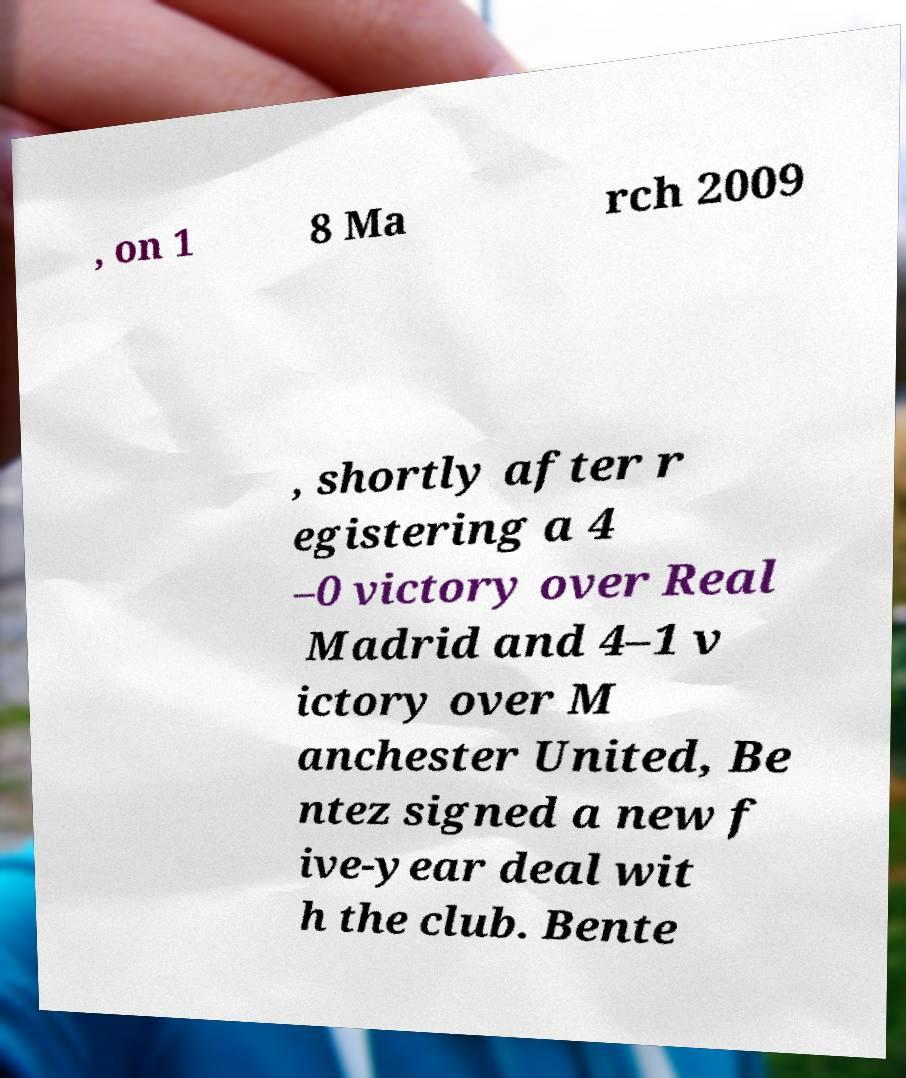Can you read and provide the text displayed in the image?This photo seems to have some interesting text. Can you extract and type it out for me? , on 1 8 Ma rch 2009 , shortly after r egistering a 4 –0 victory over Real Madrid and 4–1 v ictory over M anchester United, Be ntez signed a new f ive-year deal wit h the club. Bente 